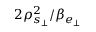<formula> <loc_0><loc_0><loc_500><loc_500>2 \rho _ { s _ { \perp } } ^ { 2 } / \beta _ { e _ { \perp } }</formula> 